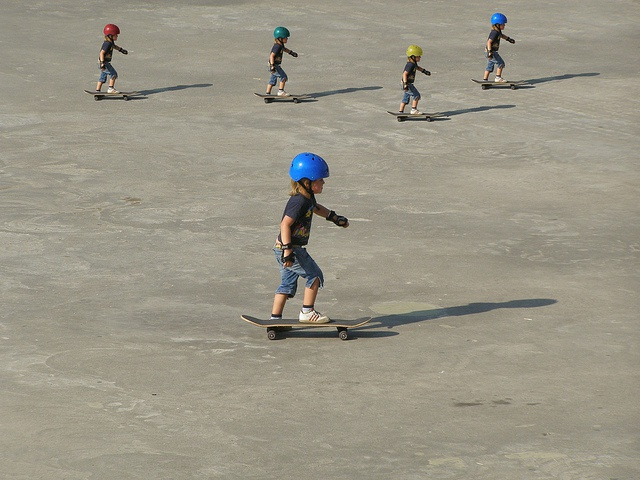Describe the objects in this image and their specific colors. I can see people in gray, black, darkgray, and maroon tones, people in gray, black, darkgray, and tan tones, people in gray, black, darkgray, and teal tones, people in gray, black, darkgray, and navy tones, and skateboard in gray, black, and tan tones in this image. 